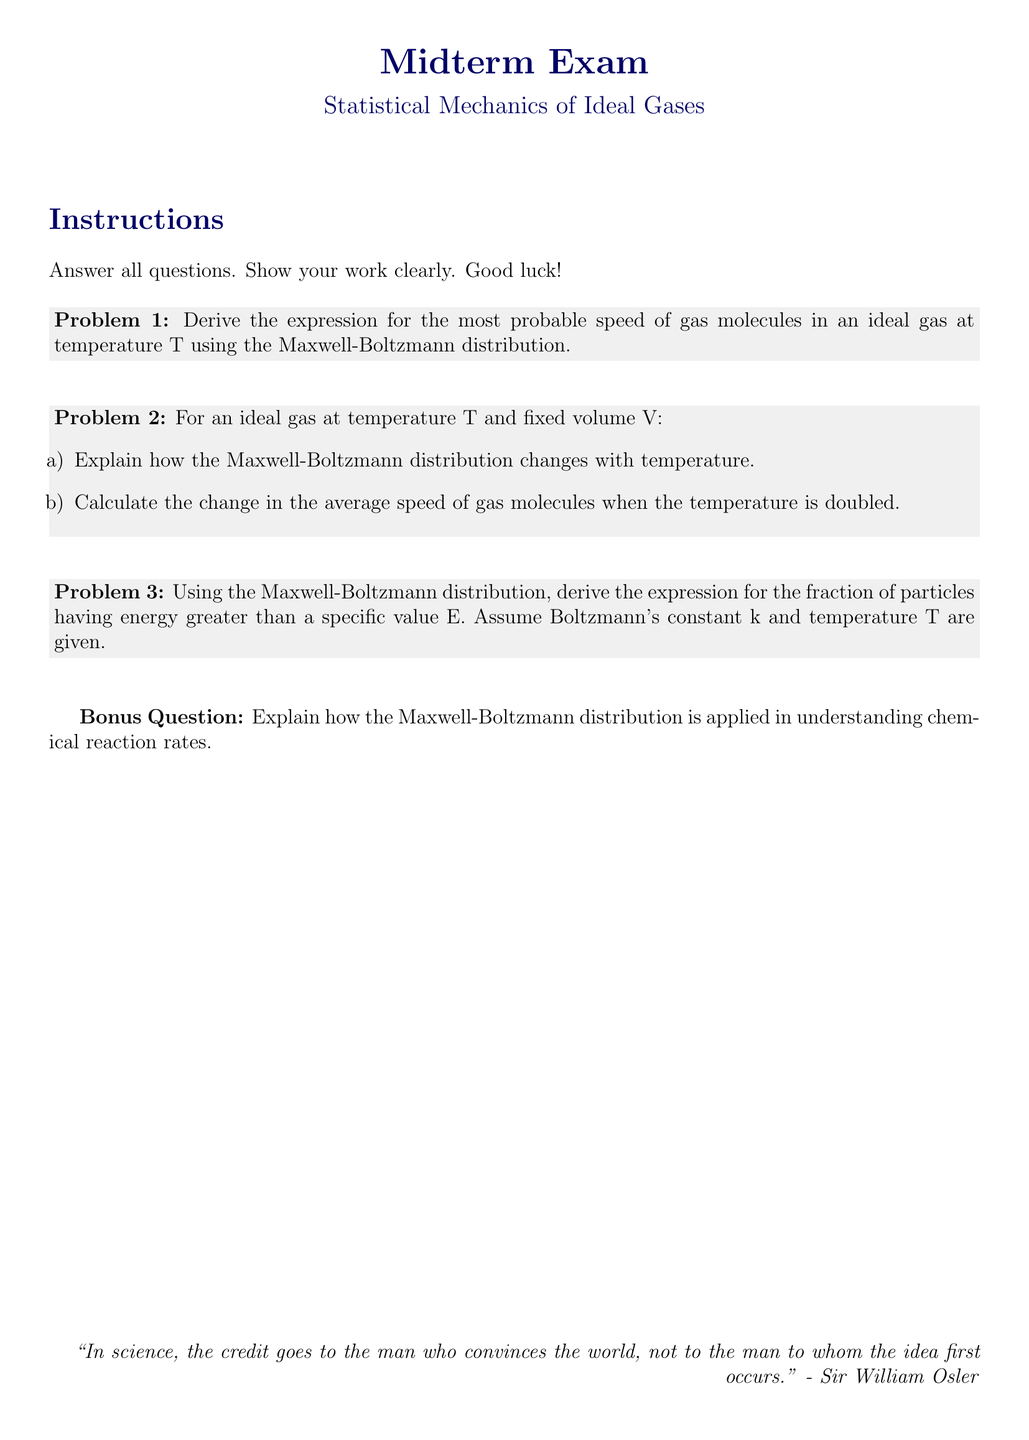What is the title of the midterm exam? The title of the midterm exam is found prominently at the top of the document, stating the focus of the exam.
Answer: Midterm Exam What are the main topics covered in this midterm exam? The main topics can be discerned from the subtitle that follows the title in the document, indicating its subject matter.
Answer: Statistical Mechanics of Ideal Gases How many problems are included in the exam? The problems are listed in a sequential numerical format, which helps identify the total count of problems presented.
Answer: 3 What is the bonus question about? The bonus question is related to a specific application of the Maxwell-Boltzmann distribution, which is mentioned in the document.
Answer: Understanding chemical reaction rates What is required in the instructions for answering the exam questions? The instructions provide guidelines on how to approach the exam questions, specifically stating what is required from the students.
Answer: Show your work clearly What variables are assumed to be given in Problem 3? The variables mentioned in Problem 3 are relevant to the Maxwell-Boltzmann distribution and the context of the problem.
Answer: Boltzmann's constant and temperature What is the topic of Problem 2 (part b)? Problem 2 (part b) requests a specific calculation related to a change in a variable at a defined state, guiding the student on what to analyze.
Answer: Change in the average speed of gas molecules What is the significance of the quote at the bottom of the document? The quote serves to encapsulate a key philosophical perspective relevant to the scientific endeavor, adding depth to the document.
Answer: Credit in science Which equation is being derived in Problem 1? Problem 1 focuses on deriving a specific expression related to the behavior of gas molecules, central to the study of statistical mechanics.
Answer: Most probable speed of gas molecules 